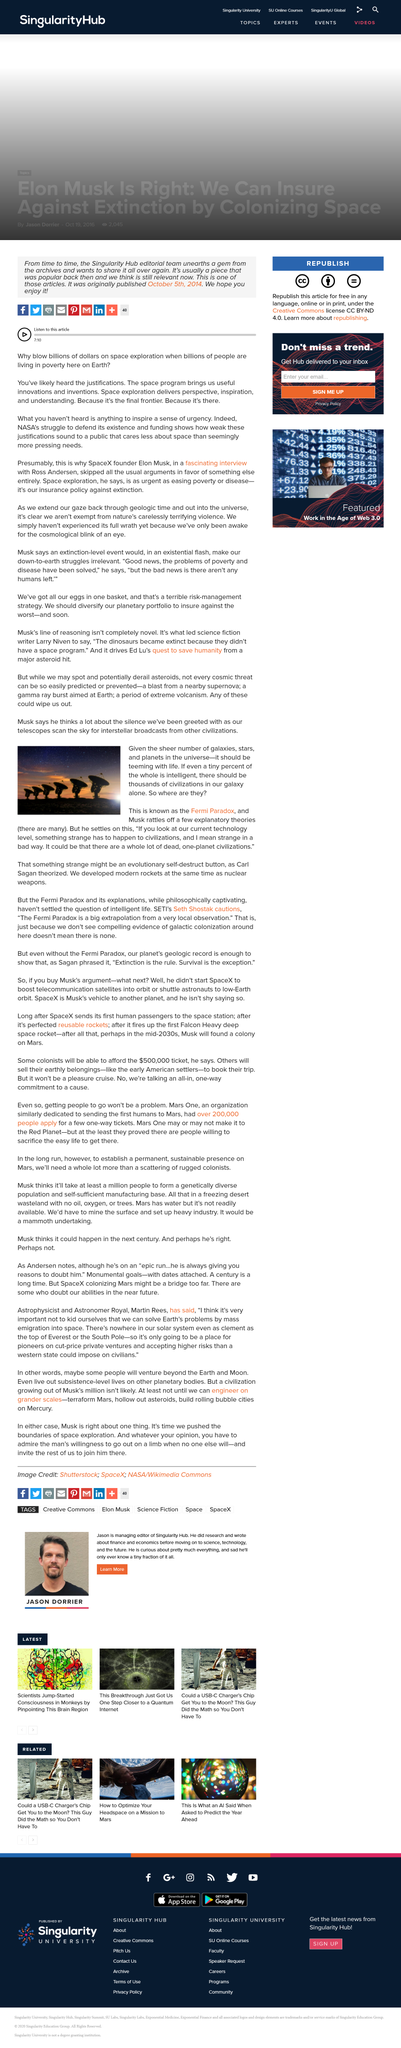Give some essential details in this illustration. We developed modern rockets at the same time as nuclear weapons, demonstrating our technological prowess and military might. It is estimated that if even a small fraction of the whole is intelligent, there should be thousands of civilizations in our galaxy. The Fermi Paradox was theorized about by Elon Musk and Carl Sagan in the article. 